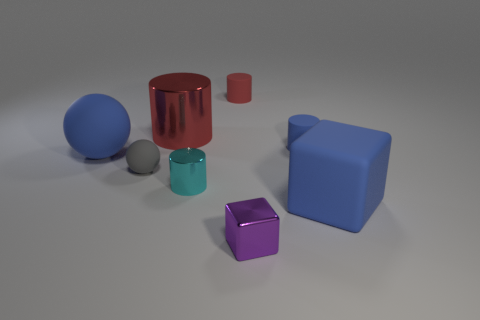Subtract all big shiny cylinders. How many cylinders are left? 3 Subtract 1 cylinders. How many cylinders are left? 3 Subtract all blue cylinders. How many cylinders are left? 3 Add 1 tiny green blocks. How many objects exist? 9 Subtract all gray cylinders. Subtract all yellow cubes. How many cylinders are left? 4 Subtract all purple blocks. Subtract all purple shiny objects. How many objects are left? 6 Add 7 large blue matte objects. How many large blue matte objects are left? 9 Add 6 tiny rubber balls. How many tiny rubber balls exist? 7 Subtract 0 green spheres. How many objects are left? 8 